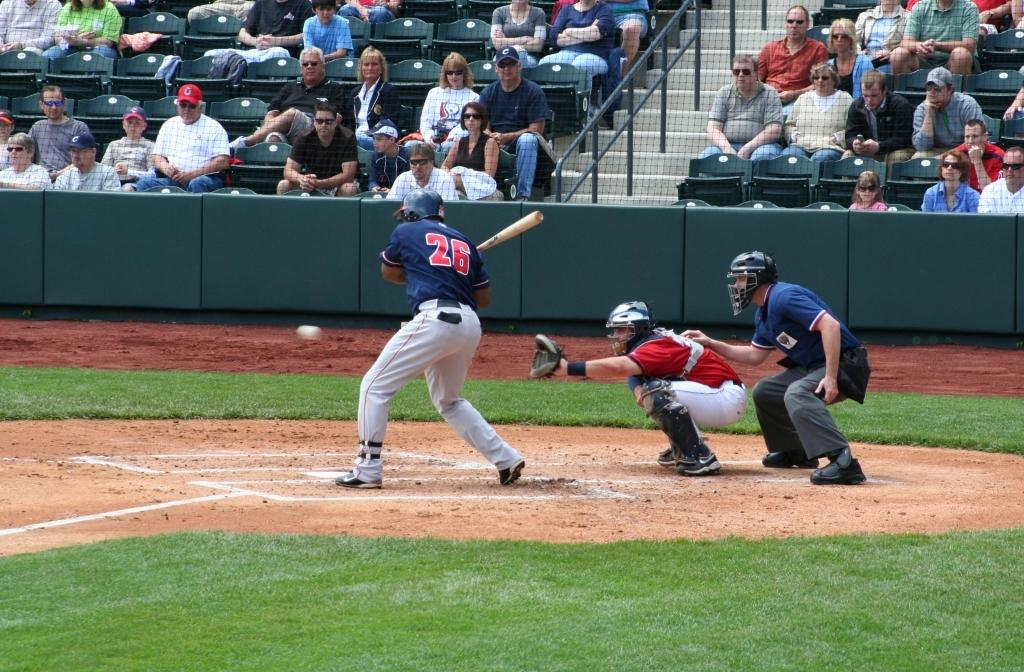<image>
Describe the image concisely. The player that is batting is wearing the number 26 